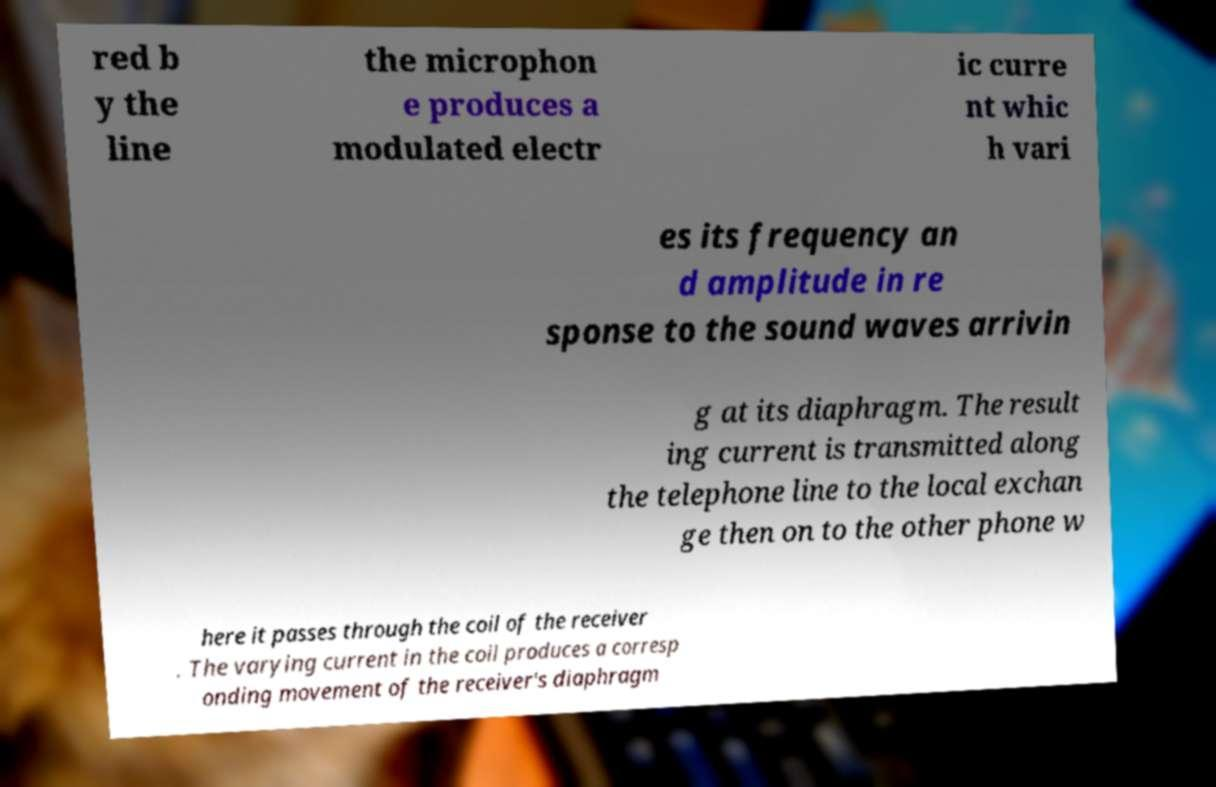What messages or text are displayed in this image? I need them in a readable, typed format. red b y the line the microphon e produces a modulated electr ic curre nt whic h vari es its frequency an d amplitude in re sponse to the sound waves arrivin g at its diaphragm. The result ing current is transmitted along the telephone line to the local exchan ge then on to the other phone w here it passes through the coil of the receiver . The varying current in the coil produces a corresp onding movement of the receiver's diaphragm 